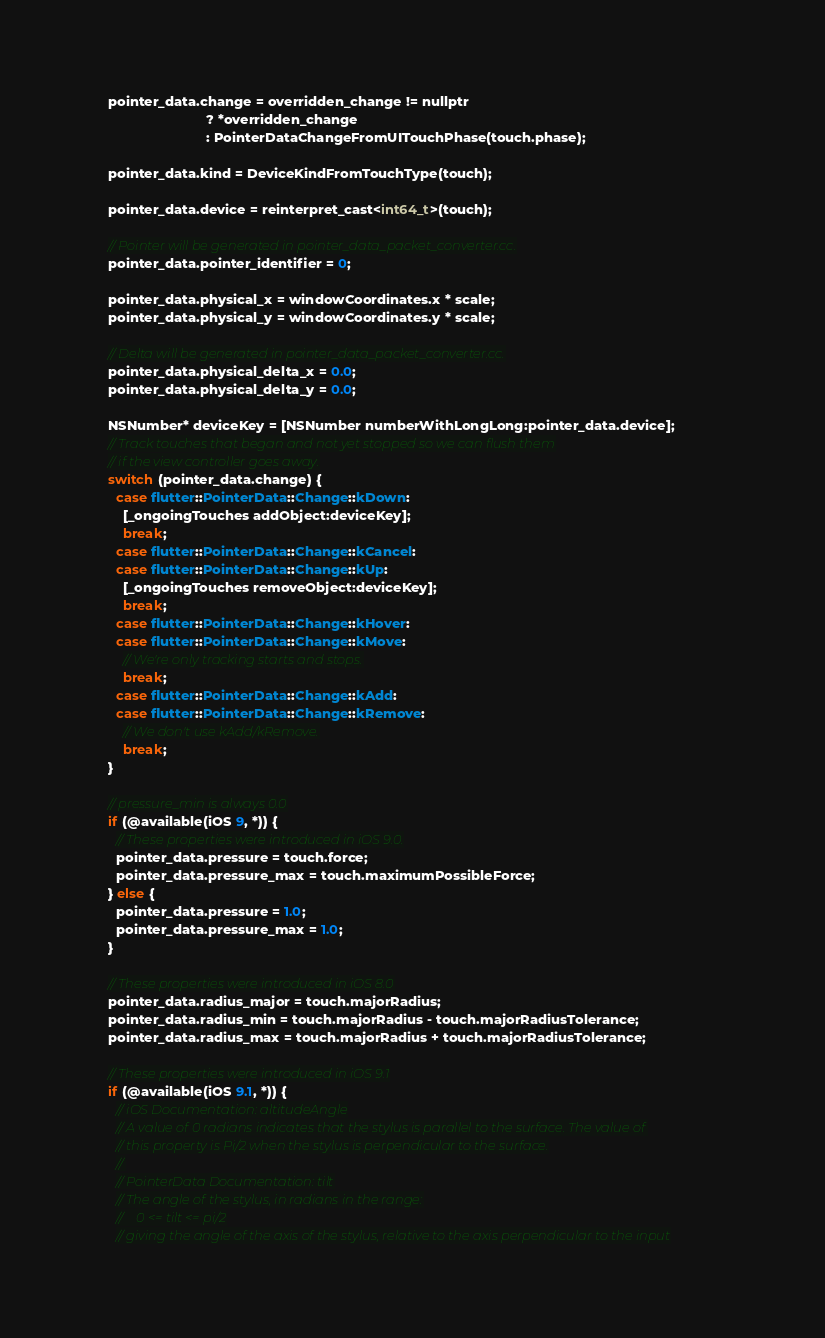<code> <loc_0><loc_0><loc_500><loc_500><_ObjectiveC_>
    pointer_data.change = overridden_change != nullptr
                              ? *overridden_change
                              : PointerDataChangeFromUITouchPhase(touch.phase);

    pointer_data.kind = DeviceKindFromTouchType(touch);

    pointer_data.device = reinterpret_cast<int64_t>(touch);

    // Pointer will be generated in pointer_data_packet_converter.cc.
    pointer_data.pointer_identifier = 0;

    pointer_data.physical_x = windowCoordinates.x * scale;
    pointer_data.physical_y = windowCoordinates.y * scale;

    // Delta will be generated in pointer_data_packet_converter.cc.
    pointer_data.physical_delta_x = 0.0;
    pointer_data.physical_delta_y = 0.0;

    NSNumber* deviceKey = [NSNumber numberWithLongLong:pointer_data.device];
    // Track touches that began and not yet stopped so we can flush them
    // if the view controller goes away.
    switch (pointer_data.change) {
      case flutter::PointerData::Change::kDown:
        [_ongoingTouches addObject:deviceKey];
        break;
      case flutter::PointerData::Change::kCancel:
      case flutter::PointerData::Change::kUp:
        [_ongoingTouches removeObject:deviceKey];
        break;
      case flutter::PointerData::Change::kHover:
      case flutter::PointerData::Change::kMove:
        // We're only tracking starts and stops.
        break;
      case flutter::PointerData::Change::kAdd:
      case flutter::PointerData::Change::kRemove:
        // We don't use kAdd/kRemove.
        break;
    }

    // pressure_min is always 0.0
    if (@available(iOS 9, *)) {
      // These properties were introduced in iOS 9.0.
      pointer_data.pressure = touch.force;
      pointer_data.pressure_max = touch.maximumPossibleForce;
    } else {
      pointer_data.pressure = 1.0;
      pointer_data.pressure_max = 1.0;
    }

    // These properties were introduced in iOS 8.0
    pointer_data.radius_major = touch.majorRadius;
    pointer_data.radius_min = touch.majorRadius - touch.majorRadiusTolerance;
    pointer_data.radius_max = touch.majorRadius + touch.majorRadiusTolerance;

    // These properties were introduced in iOS 9.1
    if (@available(iOS 9.1, *)) {
      // iOS Documentation: altitudeAngle
      // A value of 0 radians indicates that the stylus is parallel to the surface. The value of
      // this property is Pi/2 when the stylus is perpendicular to the surface.
      //
      // PointerData Documentation: tilt
      // The angle of the stylus, in radians in the range:
      //    0 <= tilt <= pi/2
      // giving the angle of the axis of the stylus, relative to the axis perpendicular to the input</code> 